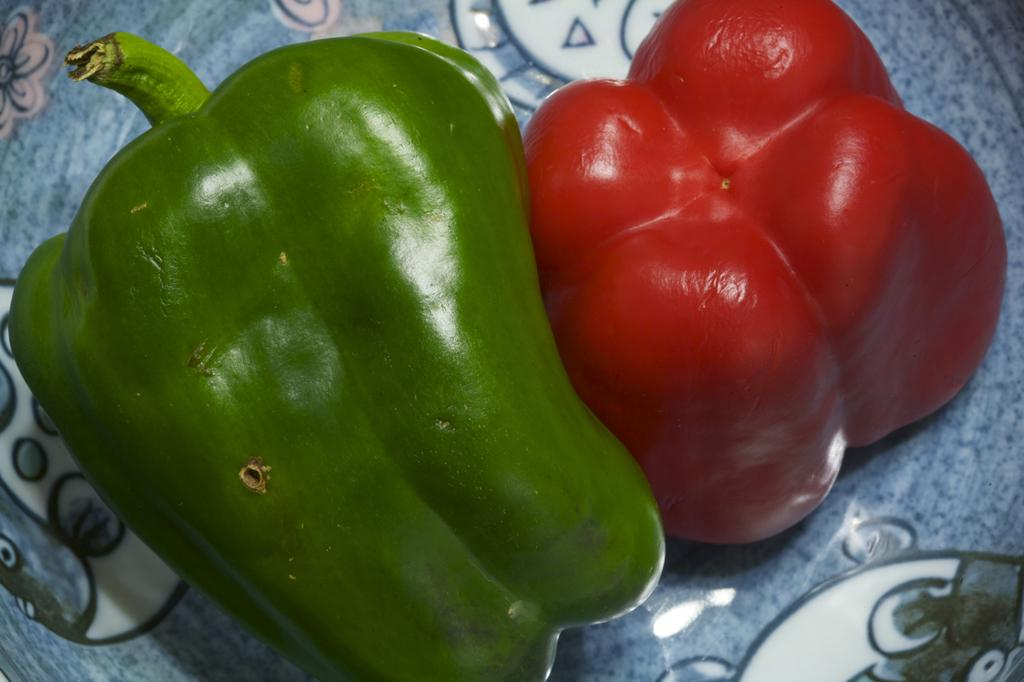What type of peppers can be seen on the surface in the image? There are green peppers and red peppers on the surface in the image. Can you describe the colors of the peppers? The green peppers are green, and the red peppers are red. How many pigs are holding the chain in the image? There are no pigs or chains present in the image; it only features green and red peppers on a surface. 